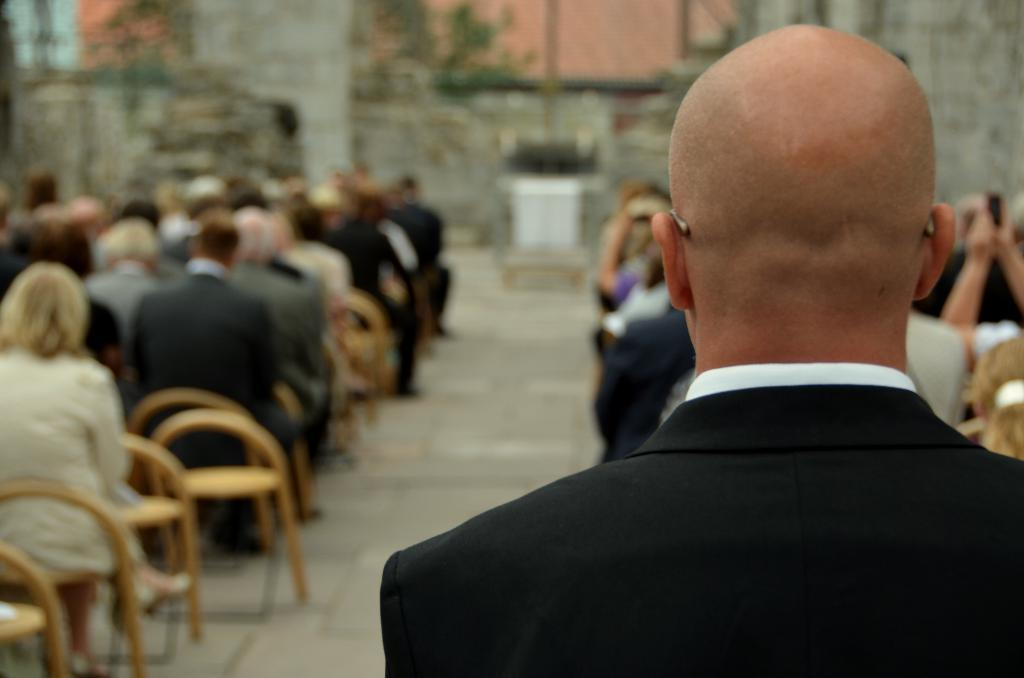What is the man in the image wearing? The man in the image is wearing a black blazer. What are the people in the image doing? The groups of people are sitting on chairs in front of the man. Can you describe any other objects or features in the image? There are some blurred objects in the image. What type of waste can be seen being recycled in the image? There is no waste or recycling depicted in the image. 